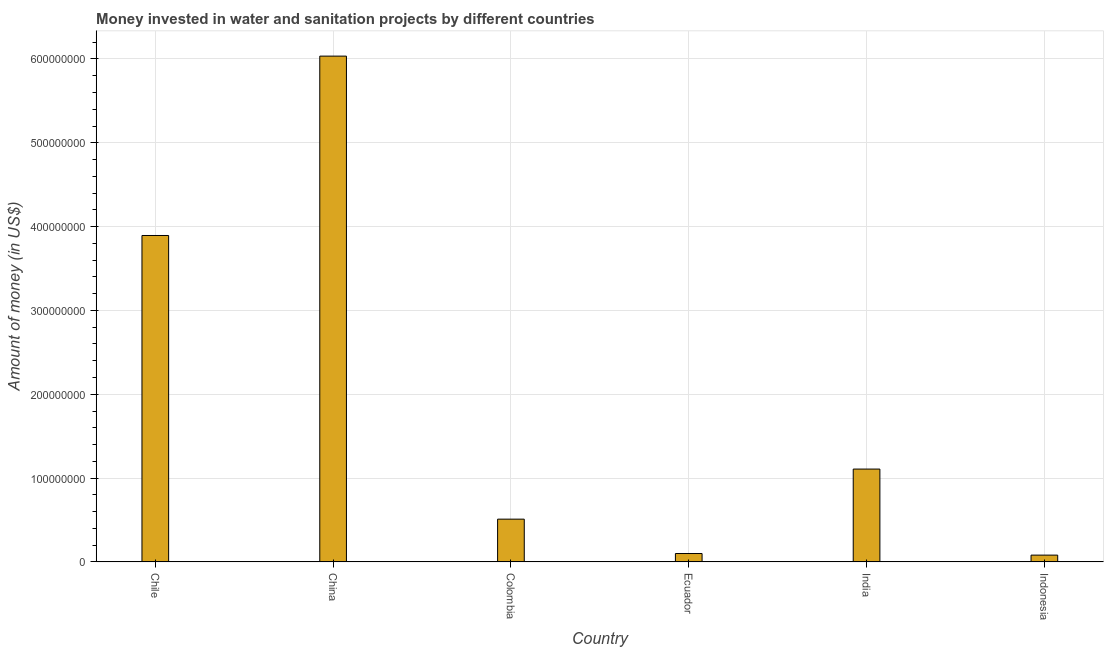Does the graph contain any zero values?
Offer a terse response. No. Does the graph contain grids?
Offer a very short reply. Yes. What is the title of the graph?
Provide a short and direct response. Money invested in water and sanitation projects by different countries. What is the label or title of the Y-axis?
Keep it short and to the point. Amount of money (in US$). Across all countries, what is the maximum investment?
Offer a terse response. 6.03e+08. Across all countries, what is the minimum investment?
Give a very brief answer. 8.10e+06. In which country was the investment maximum?
Ensure brevity in your answer.  China. What is the sum of the investment?
Provide a succinct answer. 1.17e+09. What is the difference between the investment in Chile and Ecuador?
Keep it short and to the point. 3.79e+08. What is the average investment per country?
Provide a succinct answer. 1.95e+08. What is the median investment?
Provide a succinct answer. 8.09e+07. In how many countries, is the investment greater than 480000000 US$?
Ensure brevity in your answer.  1. What is the ratio of the investment in Ecuador to that in Indonesia?
Give a very brief answer. 1.24. Is the difference between the investment in Chile and Ecuador greater than the difference between any two countries?
Ensure brevity in your answer.  No. What is the difference between the highest and the second highest investment?
Keep it short and to the point. 2.14e+08. Is the sum of the investment in Chile and Colombia greater than the maximum investment across all countries?
Your response must be concise. No. What is the difference between the highest and the lowest investment?
Offer a terse response. 5.95e+08. In how many countries, is the investment greater than the average investment taken over all countries?
Your answer should be compact. 2. How many bars are there?
Ensure brevity in your answer.  6. Are all the bars in the graph horizontal?
Keep it short and to the point. No. How many countries are there in the graph?
Ensure brevity in your answer.  6. What is the difference between two consecutive major ticks on the Y-axis?
Ensure brevity in your answer.  1.00e+08. What is the Amount of money (in US$) of Chile?
Keep it short and to the point. 3.89e+08. What is the Amount of money (in US$) in China?
Provide a short and direct response. 6.03e+08. What is the Amount of money (in US$) in Colombia?
Provide a short and direct response. 5.10e+07. What is the Amount of money (in US$) in India?
Your answer should be compact. 1.11e+08. What is the Amount of money (in US$) of Indonesia?
Your response must be concise. 8.10e+06. What is the difference between the Amount of money (in US$) in Chile and China?
Your answer should be compact. -2.14e+08. What is the difference between the Amount of money (in US$) in Chile and Colombia?
Provide a succinct answer. 3.38e+08. What is the difference between the Amount of money (in US$) in Chile and Ecuador?
Keep it short and to the point. 3.79e+08. What is the difference between the Amount of money (in US$) in Chile and India?
Your answer should be compact. 2.79e+08. What is the difference between the Amount of money (in US$) in Chile and Indonesia?
Provide a succinct answer. 3.81e+08. What is the difference between the Amount of money (in US$) in China and Colombia?
Ensure brevity in your answer.  5.52e+08. What is the difference between the Amount of money (in US$) in China and Ecuador?
Provide a short and direct response. 5.93e+08. What is the difference between the Amount of money (in US$) in China and India?
Ensure brevity in your answer.  4.93e+08. What is the difference between the Amount of money (in US$) in China and Indonesia?
Offer a very short reply. 5.95e+08. What is the difference between the Amount of money (in US$) in Colombia and Ecuador?
Your response must be concise. 4.10e+07. What is the difference between the Amount of money (in US$) in Colombia and India?
Make the answer very short. -5.98e+07. What is the difference between the Amount of money (in US$) in Colombia and Indonesia?
Give a very brief answer. 4.29e+07. What is the difference between the Amount of money (in US$) in Ecuador and India?
Ensure brevity in your answer.  -1.01e+08. What is the difference between the Amount of money (in US$) in Ecuador and Indonesia?
Your answer should be compact. 1.90e+06. What is the difference between the Amount of money (in US$) in India and Indonesia?
Your answer should be very brief. 1.03e+08. What is the ratio of the Amount of money (in US$) in Chile to that in China?
Provide a succinct answer. 0.65. What is the ratio of the Amount of money (in US$) in Chile to that in Colombia?
Make the answer very short. 7.63. What is the ratio of the Amount of money (in US$) in Chile to that in Ecuador?
Offer a terse response. 38.94. What is the ratio of the Amount of money (in US$) in Chile to that in India?
Your answer should be very brief. 3.52. What is the ratio of the Amount of money (in US$) in Chile to that in Indonesia?
Offer a very short reply. 48.07. What is the ratio of the Amount of money (in US$) in China to that in Colombia?
Provide a short and direct response. 11.83. What is the ratio of the Amount of money (in US$) in China to that in Ecuador?
Your response must be concise. 60.34. What is the ratio of the Amount of money (in US$) in China to that in India?
Provide a succinct answer. 5.45. What is the ratio of the Amount of money (in US$) in China to that in Indonesia?
Offer a terse response. 74.49. What is the ratio of the Amount of money (in US$) in Colombia to that in India?
Offer a terse response. 0.46. What is the ratio of the Amount of money (in US$) in Colombia to that in Indonesia?
Your response must be concise. 6.3. What is the ratio of the Amount of money (in US$) in Ecuador to that in India?
Make the answer very short. 0.09. What is the ratio of the Amount of money (in US$) in Ecuador to that in Indonesia?
Offer a very short reply. 1.24. What is the ratio of the Amount of money (in US$) in India to that in Indonesia?
Give a very brief answer. 13.67. 